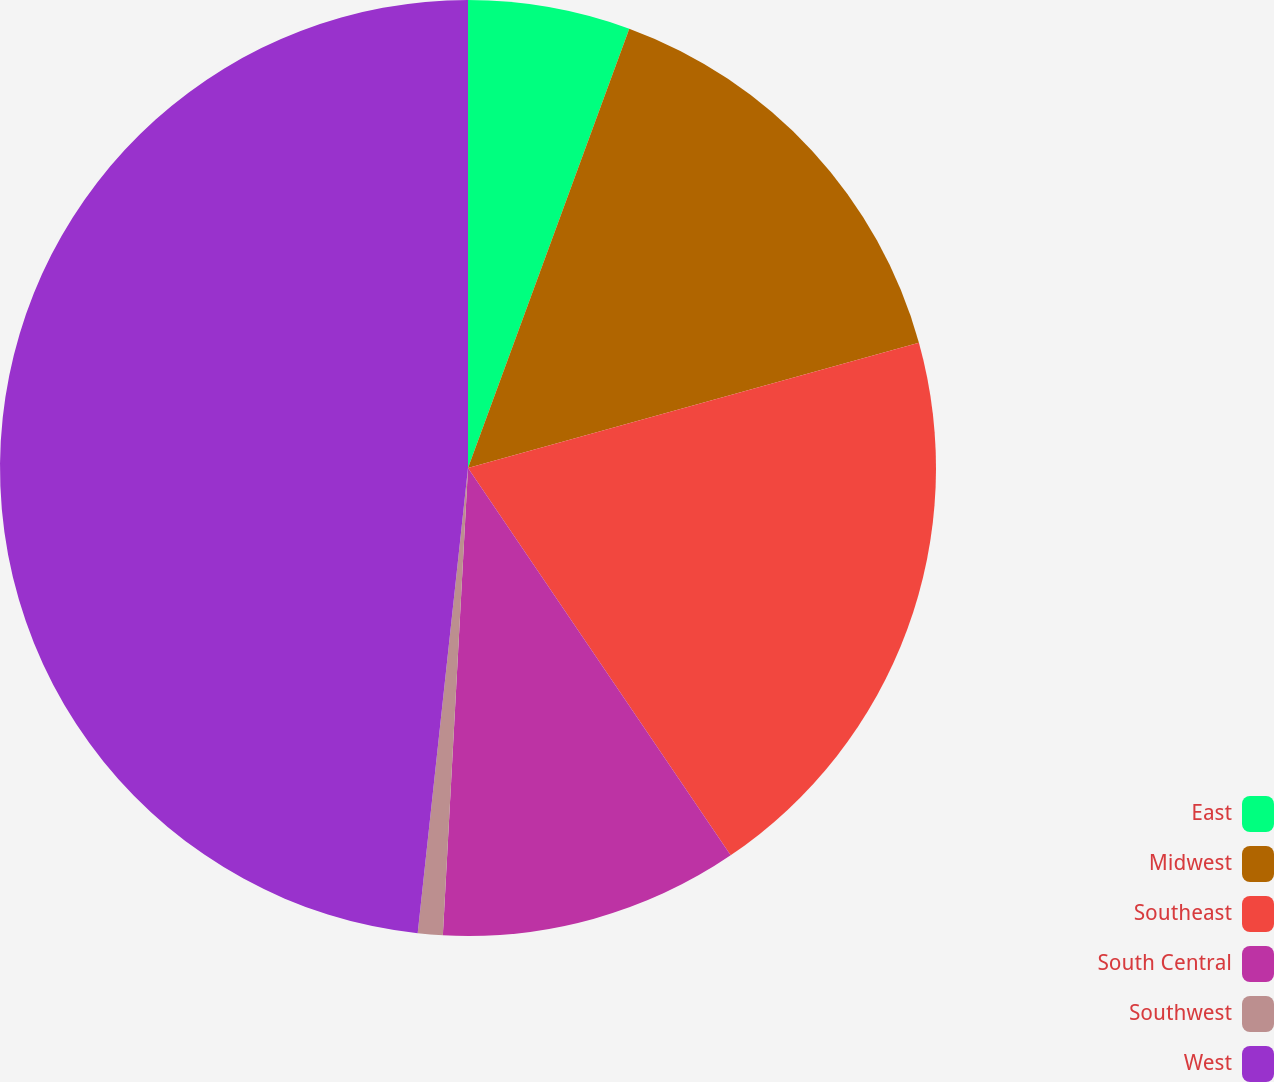Convert chart. <chart><loc_0><loc_0><loc_500><loc_500><pie_chart><fcel>East<fcel>Midwest<fcel>Southeast<fcel>South Central<fcel>Southwest<fcel>West<nl><fcel>5.6%<fcel>15.09%<fcel>19.83%<fcel>10.34%<fcel>0.86%<fcel>48.29%<nl></chart> 